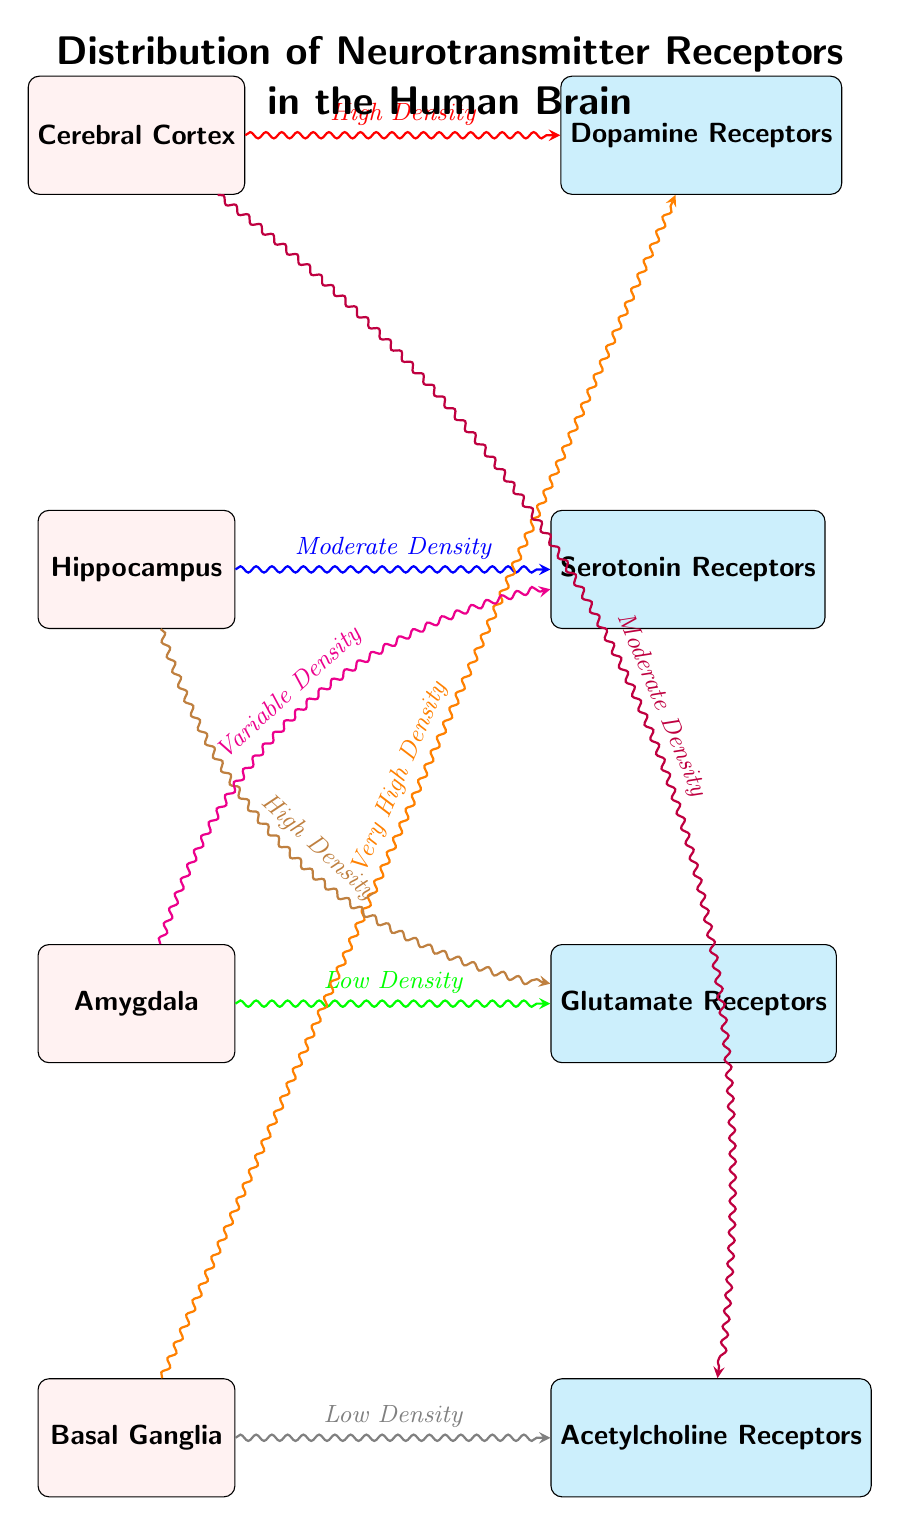What are the four brain parts represented in the diagram? The diagram includes the Cerebral Cortex, Hippocampus, Amygdala, and Basal Ganglia. These are the main nodes displayed for the areas of the brain.
Answer: Cerebral Cortex, Hippocampus, Amygdala, Basal Ganglia Which receptor has the highest density in the Basal Ganglia? The connection from the Basal Ganglia shows "Very High Density" to the Dopamine Receptors, indicating that they are most concentrated in this region.
Answer: Dopamine Receptors How many types of neurotransmitter receptors are depicted? The diagram shows four distinct receptor types: Dopamine, Serotonin, Glutamate, and Acetylcholine, which can be counted directly from the receptor nodes.
Answer: 4 What is the density of Serotonin Receptors in the Hippocampus? The connection from the Hippocampus to Serotonin Receptors is labeled with "Moderate Density," meaning there is a medium concentration of these receptors in that area.
Answer: Moderate Density Which brain part has Low Density connections to Acetylcholine Receptors? The connection from the Basal Ganglia to Acetylcholine Receptors states "Low Density," indicating this area has a sparse distribution of these specific receptors.
Answer: Basal Ganglia Which receptor has variable density and which brain part does it connect to? The Serotonin Receptors are indicated to have "Variable Density" and connect to the Amygdala, meaning that the concentration of these receptors varies in that region.
Answer: Amygdala Is the connection between the Cerebral Cortex and Dopamine Receptors considered high-density? The connection line is labeled "High Density" between the Cerebral Cortex and Dopamine Receptors, making it clear that there is a significant concentration of these receptors in the cortex.
Answer: Yes What color is used to represent connections with Very High Density? The connection indicating Very High Density is shown in orange, which can be identified by checking the color used for that particular connection in the diagram.
Answer: Orange How are the receptor types distributed with respect to brain parts? The receptors are shown positioned to the right of their corresponding brain parts with varying density labels, demonstrating the relationship and concentration of neurotransmitter receptors in specific regions.
Answer: Right of brain parts 